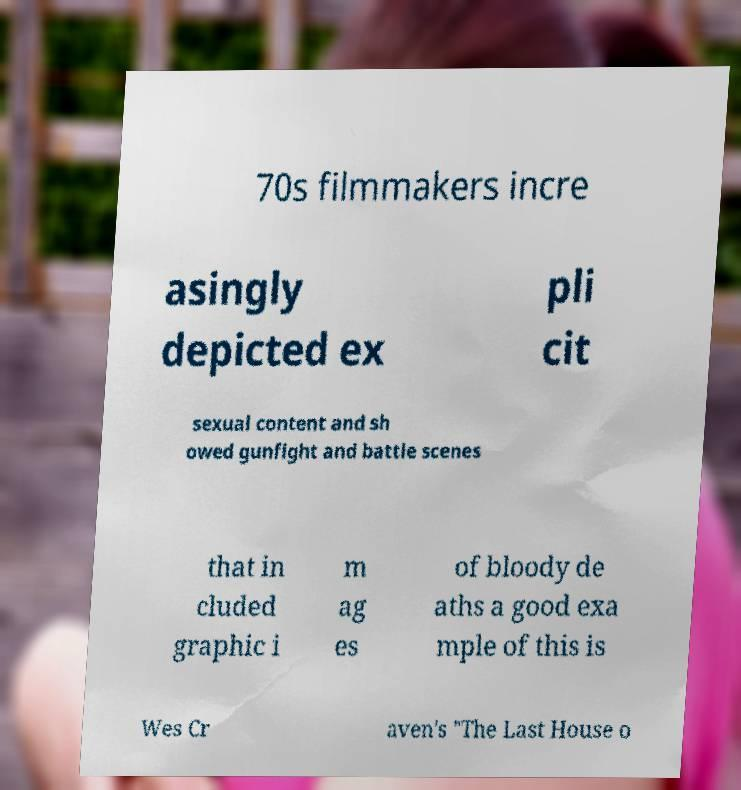I need the written content from this picture converted into text. Can you do that? 70s filmmakers incre asingly depicted ex pli cit sexual content and sh owed gunfight and battle scenes that in cluded graphic i m ag es of bloody de aths a good exa mple of this is Wes Cr aven's "The Last House o 